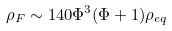Convert formula to latex. <formula><loc_0><loc_0><loc_500><loc_500>\rho _ { F } \sim 1 4 0 \Phi ^ { 3 } ( \Phi + 1 ) \rho _ { e q }</formula> 